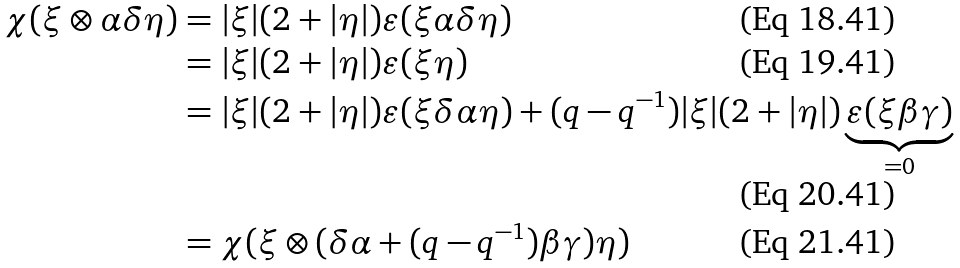<formula> <loc_0><loc_0><loc_500><loc_500>\chi ( \xi \otimes \alpha \delta \eta ) & = | \xi | ( 2 + | \eta | ) \varepsilon ( \xi \alpha \delta \eta ) \\ & = | \xi | ( 2 + | \eta | ) \varepsilon ( \xi \eta ) \\ & = | \xi | ( 2 + | \eta | ) \varepsilon ( \xi \delta \alpha \eta ) + ( q - q ^ { - 1 } ) | \xi | ( 2 + | \eta | ) \underbrace { \varepsilon ( \xi \beta \gamma ) } _ { = 0 } \\ & = \chi ( \xi \otimes ( \delta \alpha + ( q - q ^ { - 1 } ) \beta \gamma ) \eta )</formula> 